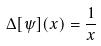Convert formula to latex. <formula><loc_0><loc_0><loc_500><loc_500>\Delta [ \psi ] ( x ) = \frac { 1 } { x }</formula> 